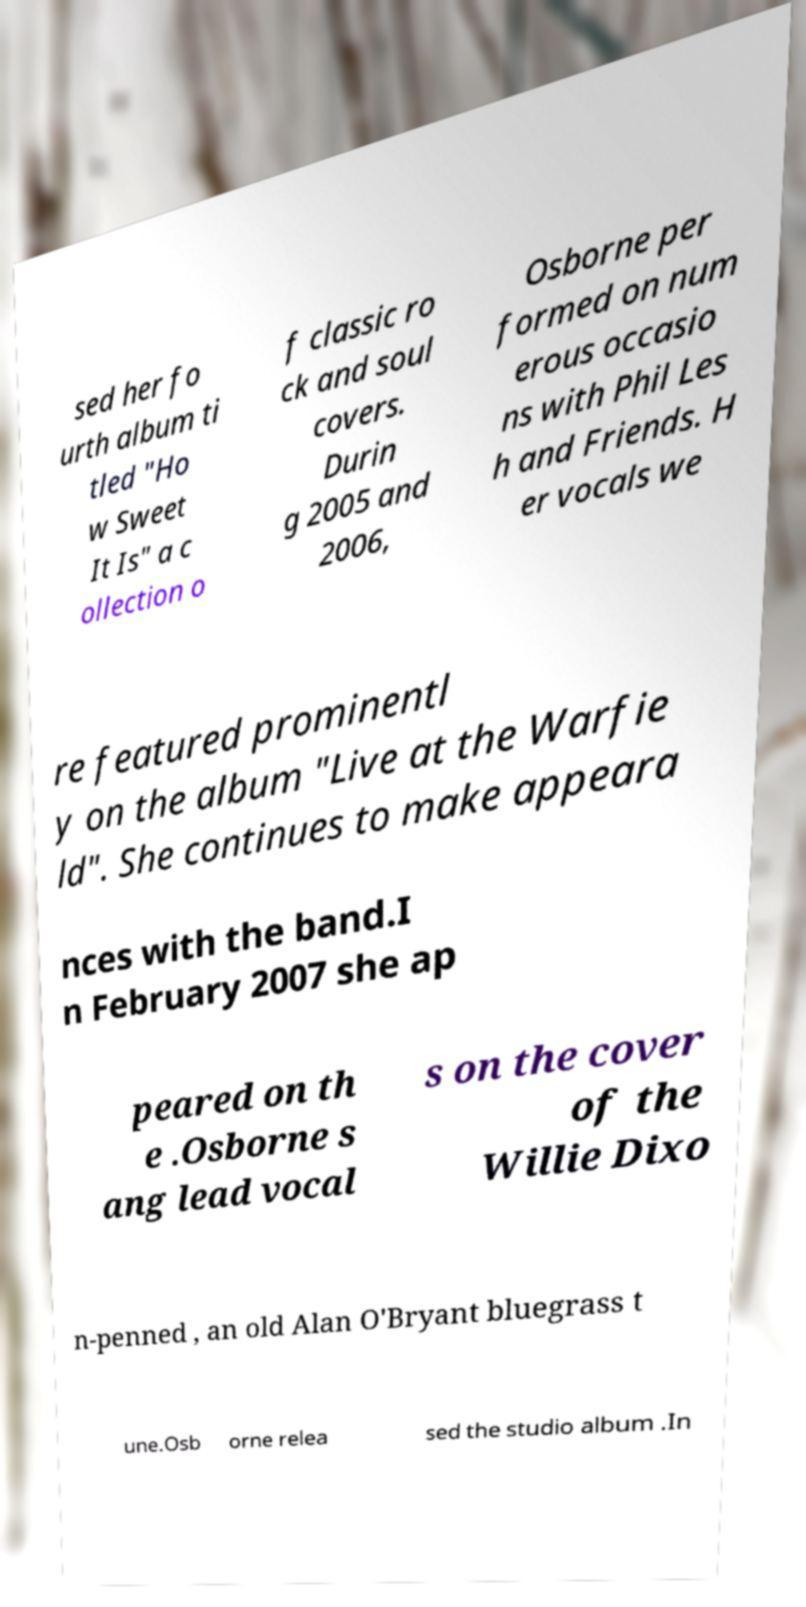There's text embedded in this image that I need extracted. Can you transcribe it verbatim? sed her fo urth album ti tled "Ho w Sweet It Is" a c ollection o f classic ro ck and soul covers. Durin g 2005 and 2006, Osborne per formed on num erous occasio ns with Phil Les h and Friends. H er vocals we re featured prominentl y on the album "Live at the Warfie ld". She continues to make appeara nces with the band.I n February 2007 she ap peared on th e .Osborne s ang lead vocal s on the cover of the Willie Dixo n-penned , an old Alan O'Bryant bluegrass t une.Osb orne relea sed the studio album .In 